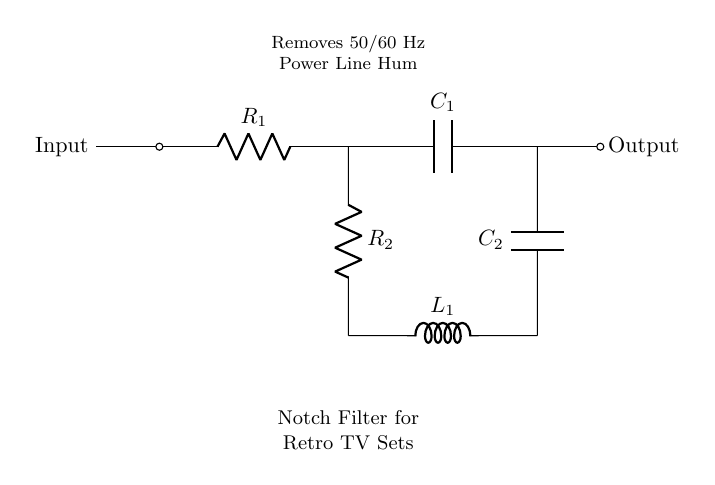What is the input of the circuit? The input is located on the left side of the diagram, showing that it is connected before the first resistor.
Answer: Input What type of filter is this circuit? The diagram explicitly states "Notch Filter" at the bottom, indicating the function of the circuit.
Answer: Notch Filter What is the purpose of the components in this circuit? The main purpose of the components, particularly the capacitor and inductor, is to filter out unwanted frequency signals, specifically the power line hum.
Answer: Filter power line hum How many resistors are in the circuit? Reviewing the circuit diagram identifies two resistors labeled R1 and R2, confirming their presence in the circuit.
Answer: Two What frequencies does this filter target? The notes on the circuit indicate that it removes 50/60 Hz signals, which correspond to typical power line hum frequencies.
Answer: 50/60 Hz How many capacitors are present in this circuit? By examining the diagram, it can be seen that there are two capacitors labeled C1 and C2, present in the circuit structure.
Answer: Two What is connected to the output? The output node, indicated by the end of the circuit on the right, shows that it is taken from the junction of C1 and the connection to resistors and inductors, meaning the filtered signal is sent from here.
Answer: Output 